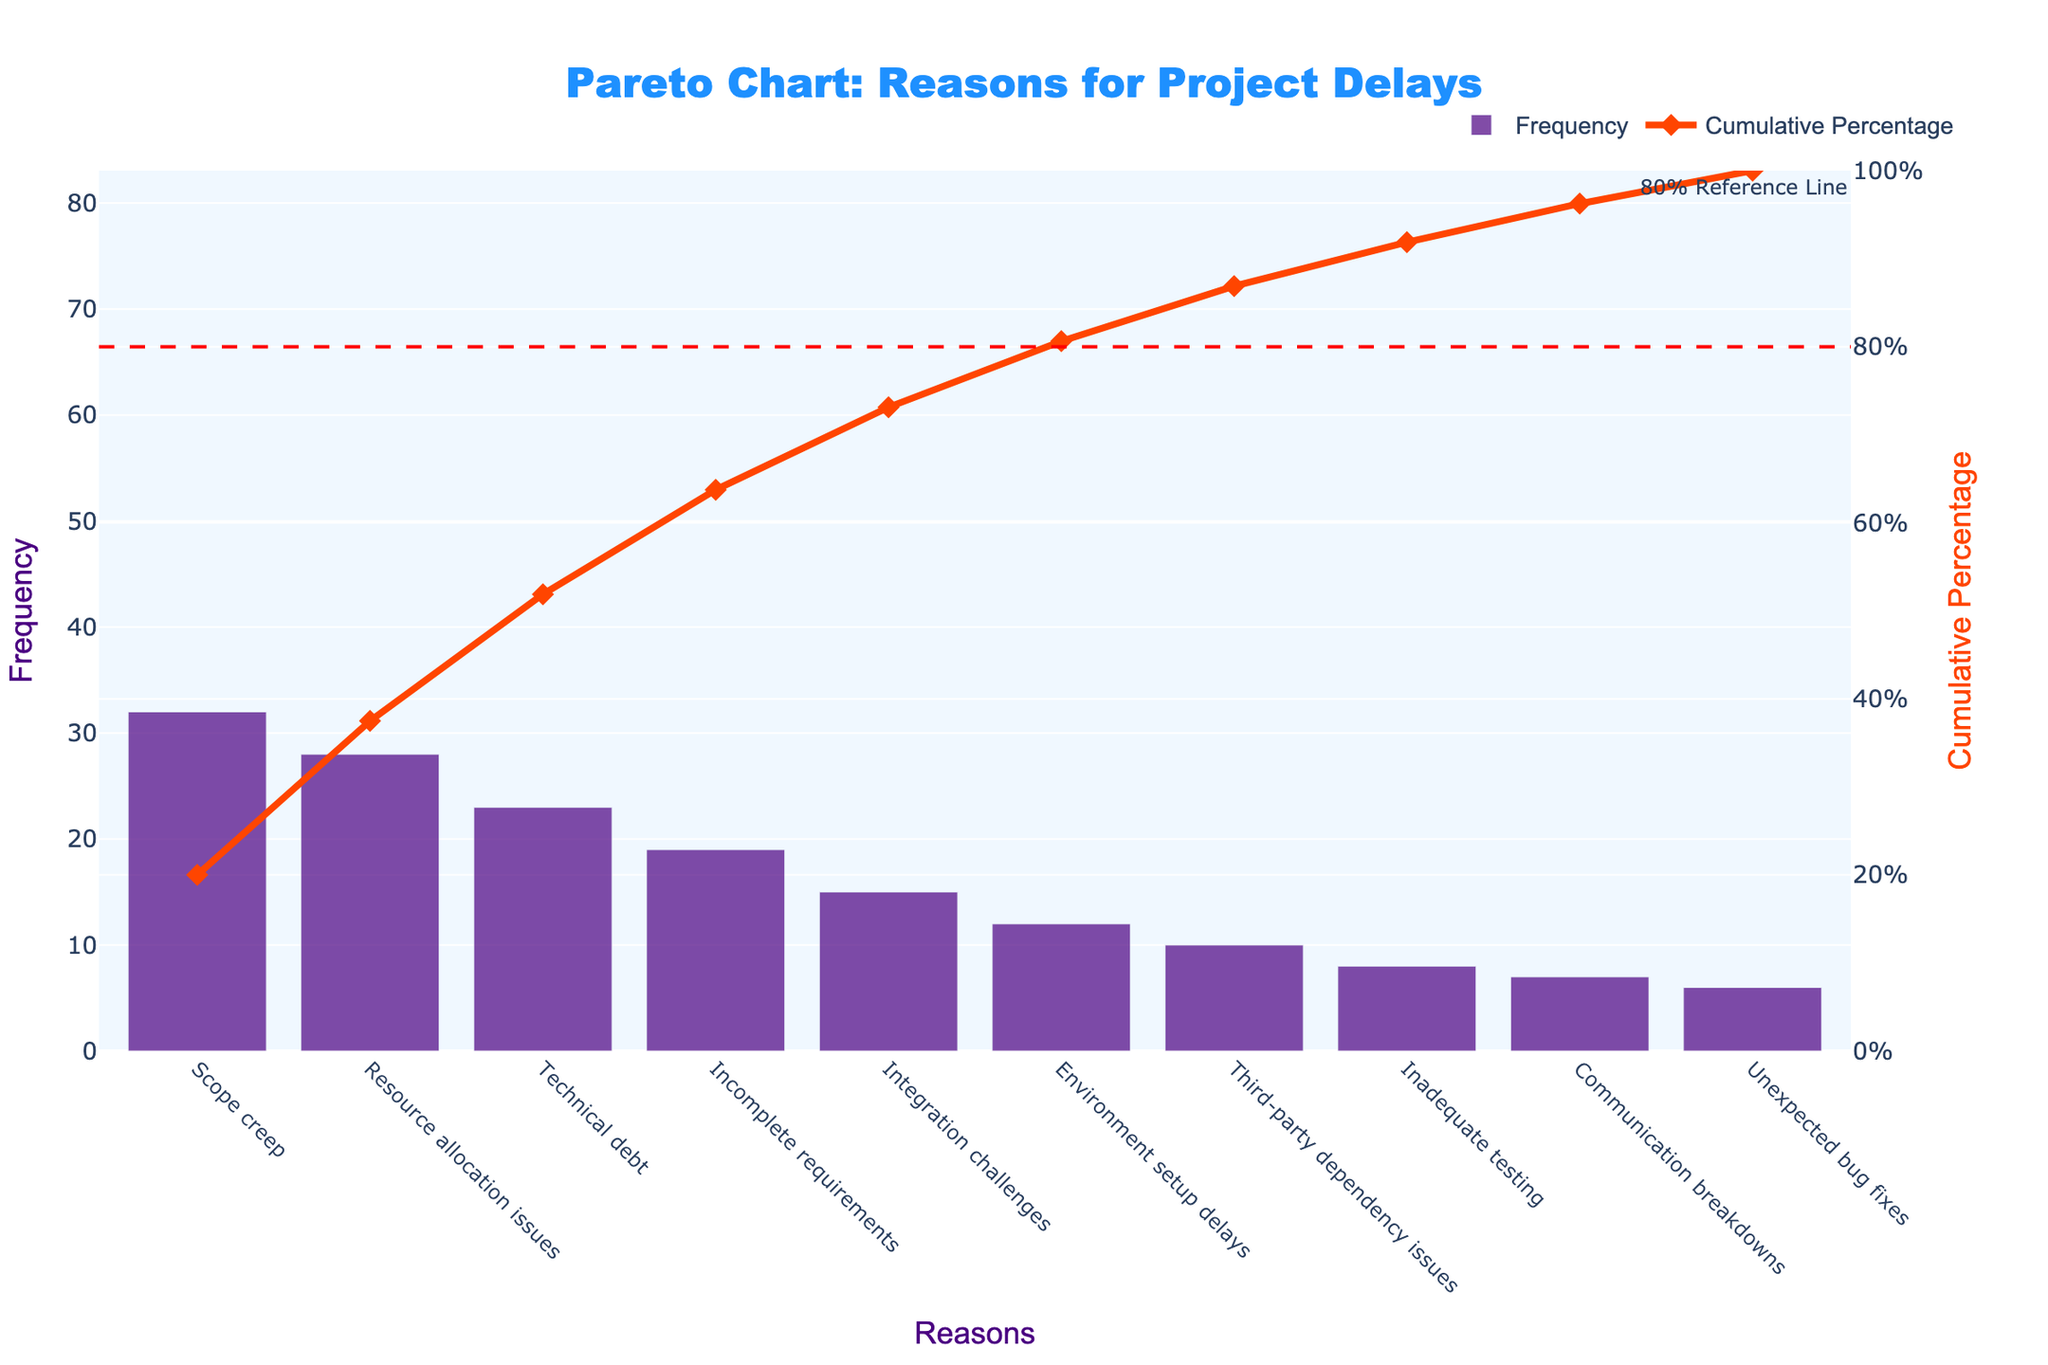What is the most frequent reason for project delays? The most frequent reason is represented by the tallest bar in the chart. In this case, it's "Scope creep" with a frequency of 32.
Answer: Scope creep What is the cumulative percentage of delays attributed to "Resource allocation issues"? Locate "Resource allocation issues" on the x-axis and refer to its cumulative percentage on the secondary y-axis. It shows approximately 57.5%.
Answer: 57.5% How many reasons account for 80% of the project delays? The 80% reference line marks the cumulative percentage where we must count the number of reasons up to the point where the line intersects the cumulative percentage curve. This intersects shortly after "Integration challenges", making 5 reasons.
Answer: 5 reasons Which reason has the lowest frequency and what is it? The shortest bar represents the reason with the lowest frequency. This bar corresponds to "Unexpected bug fixes" with a frequency of 6.
Answer: Unexpected bug fixes What is the cumulative percentage after accounting for "Incomplete requirements"? Find "Incomplete requirements" on the x-axis and check its position on the cumulative percentage curve, which is approximately around 67.5%.
Answer: 67.5% How does "Technical debt" compare to "Environment setup delays" in frequency? "Technical debt" has a frequency value and bar height greater than "Environment setup delays". Technical debt's frequency is 23, while Environment setup delays' frequency is 12.
Answer: Technical debt has a higher frequency If we resolve "Scope creep" and "Resource allocation issues", what percentage of delays would be eliminated? Add the frequencies of "Scope creep" and "Resource allocation issues" (32 + 28), then divide by the total sum of frequencies (160) and multiply by 100. (60/160 * 100 = 37.5%).
Answer: 37.5% Which reason is responsible for the greatest increase in cumulative percentage from its preceding reason? Identify the point of the largest rise in the cumulative percentage curve. Moving from "Resource allocation issues" to "Scope creep" seems to have the largest positive gap, calculation: (57.5-37.5=20).
Answer: Scope creep provides the greatest increase What insight can be drawn from the fact that "Third-party dependency issues" is positioned lower on both the frequency and cumulative percentage lists? It indicates that "Third-party dependency issues" are less common and contribute less significantly to cumulative delays comparably. Its frequency is 10, and it contributes less to the cumulative percentage curve than more frequent reasons.
Answer: Less common, lower cumulative impact 